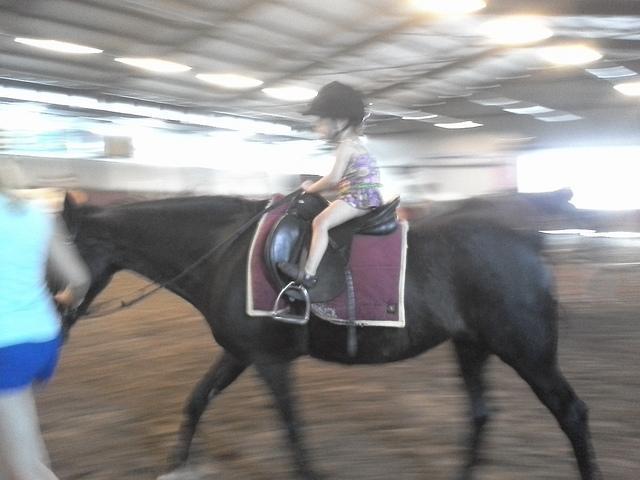How many people are in this image?
Give a very brief answer. 2. How many people are in the picture?
Give a very brief answer. 2. 